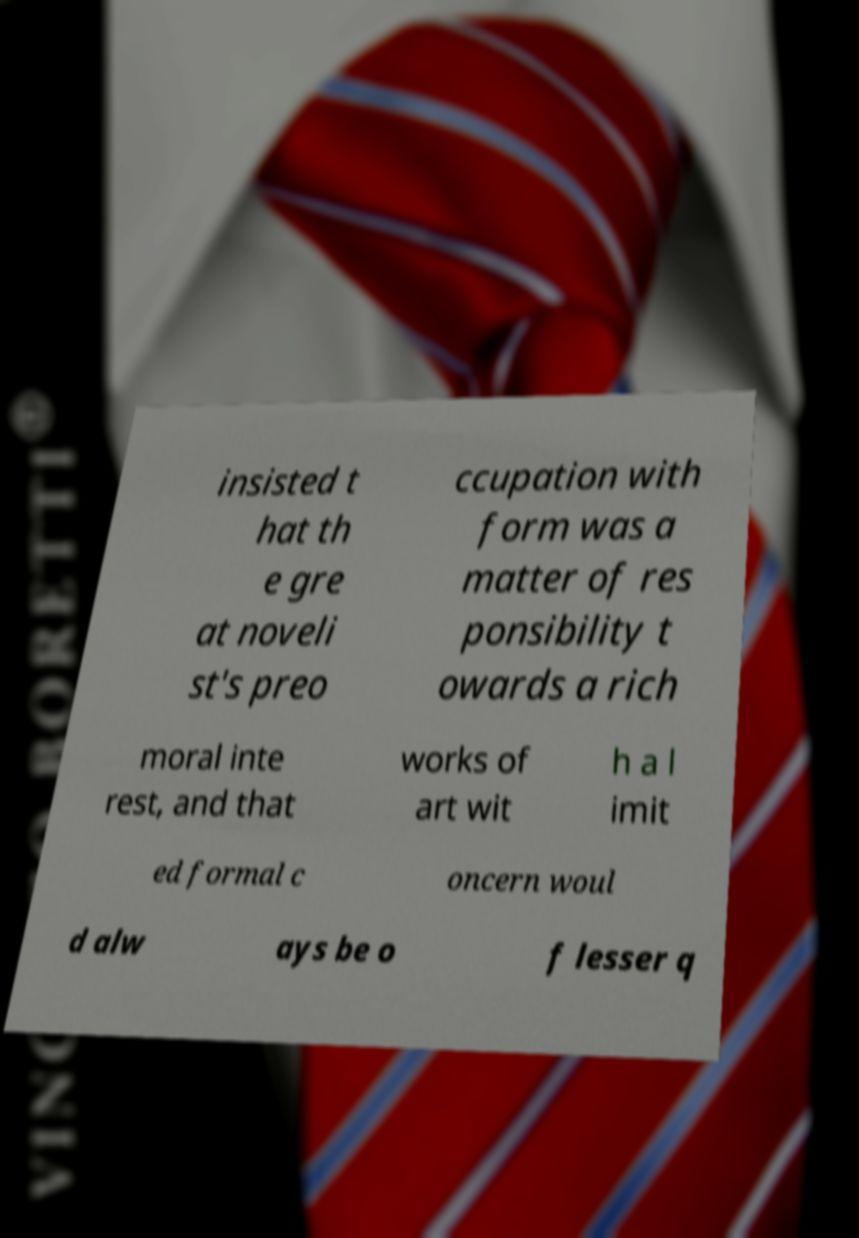What messages or text are displayed in this image? I need them in a readable, typed format. insisted t hat th e gre at noveli st's preo ccupation with form was a matter of res ponsibility t owards a rich moral inte rest, and that works of art wit h a l imit ed formal c oncern woul d alw ays be o f lesser q 